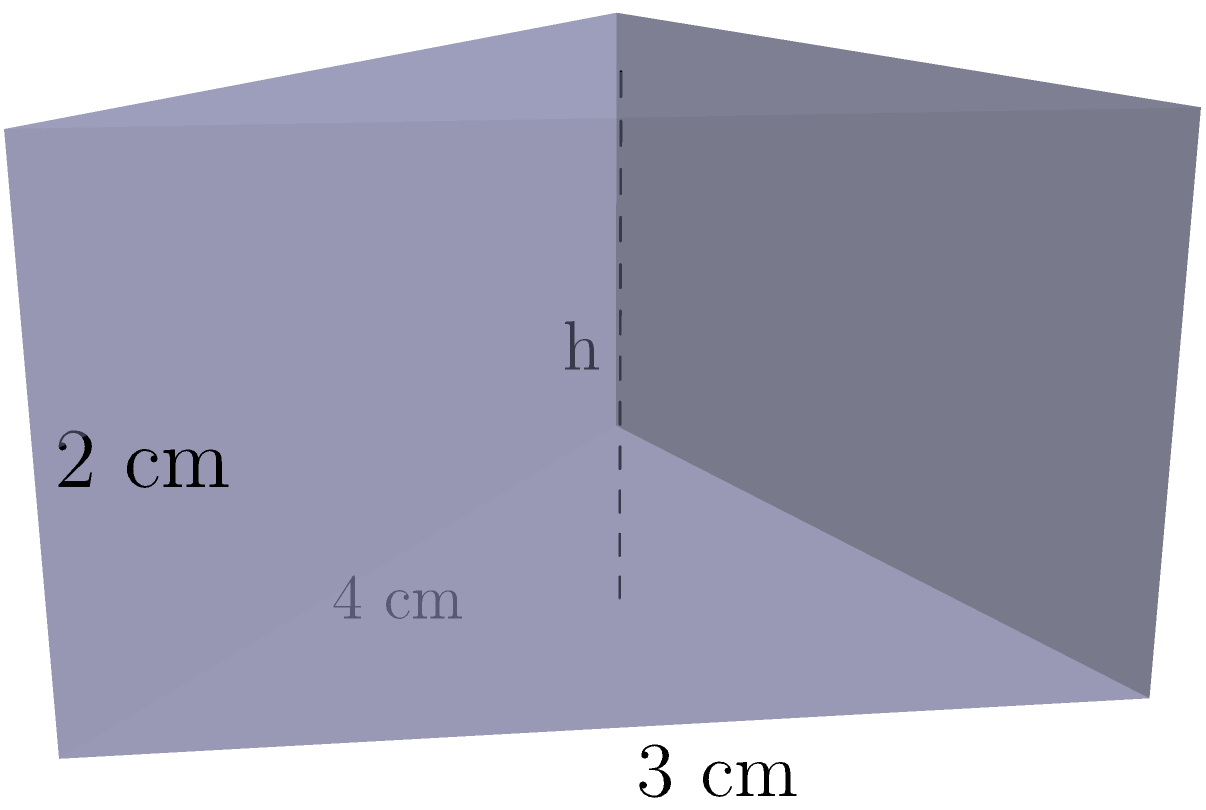For a commemorative plaque in the shape of a triangular prism, the base is an isosceles triangle with a base of 4 cm and a height of 3 cm. The prism has a depth of 2 cm. If the museum requires the plaque's volume to be at least 10 cubic centimeters, what is the minimum height (h) of the triangular face needed to meet this requirement? Let's approach this step-by-step:

1) First, we need to calculate the area of the triangular base:
   Area of triangle = $\frac{1}{2} \times base \times height$
   $A = \frac{1}{2} \times 4 \times 3 = 6$ cm²

2) Now, we can set up an equation for the volume of the prism:
   Volume = Area of base $\times$ depth
   $V = 6h \times 2 = 12h$ cm³, where h is the height we're looking for

3) We know the volume needs to be at least 10 cm³, so:
   $12h \geq 10$

4) Solving for h:
   $h \geq \frac{10}{12} = \frac{5}{6} \approx 0.833$ cm

5) Since we need the minimum height that meets the requirement, and the height must be practical for engraving, we should round up to the nearest millimeter.

Therefore, the minimum height needed is 0.834 cm or 8.34 mm.
Answer: 0.834 cm 